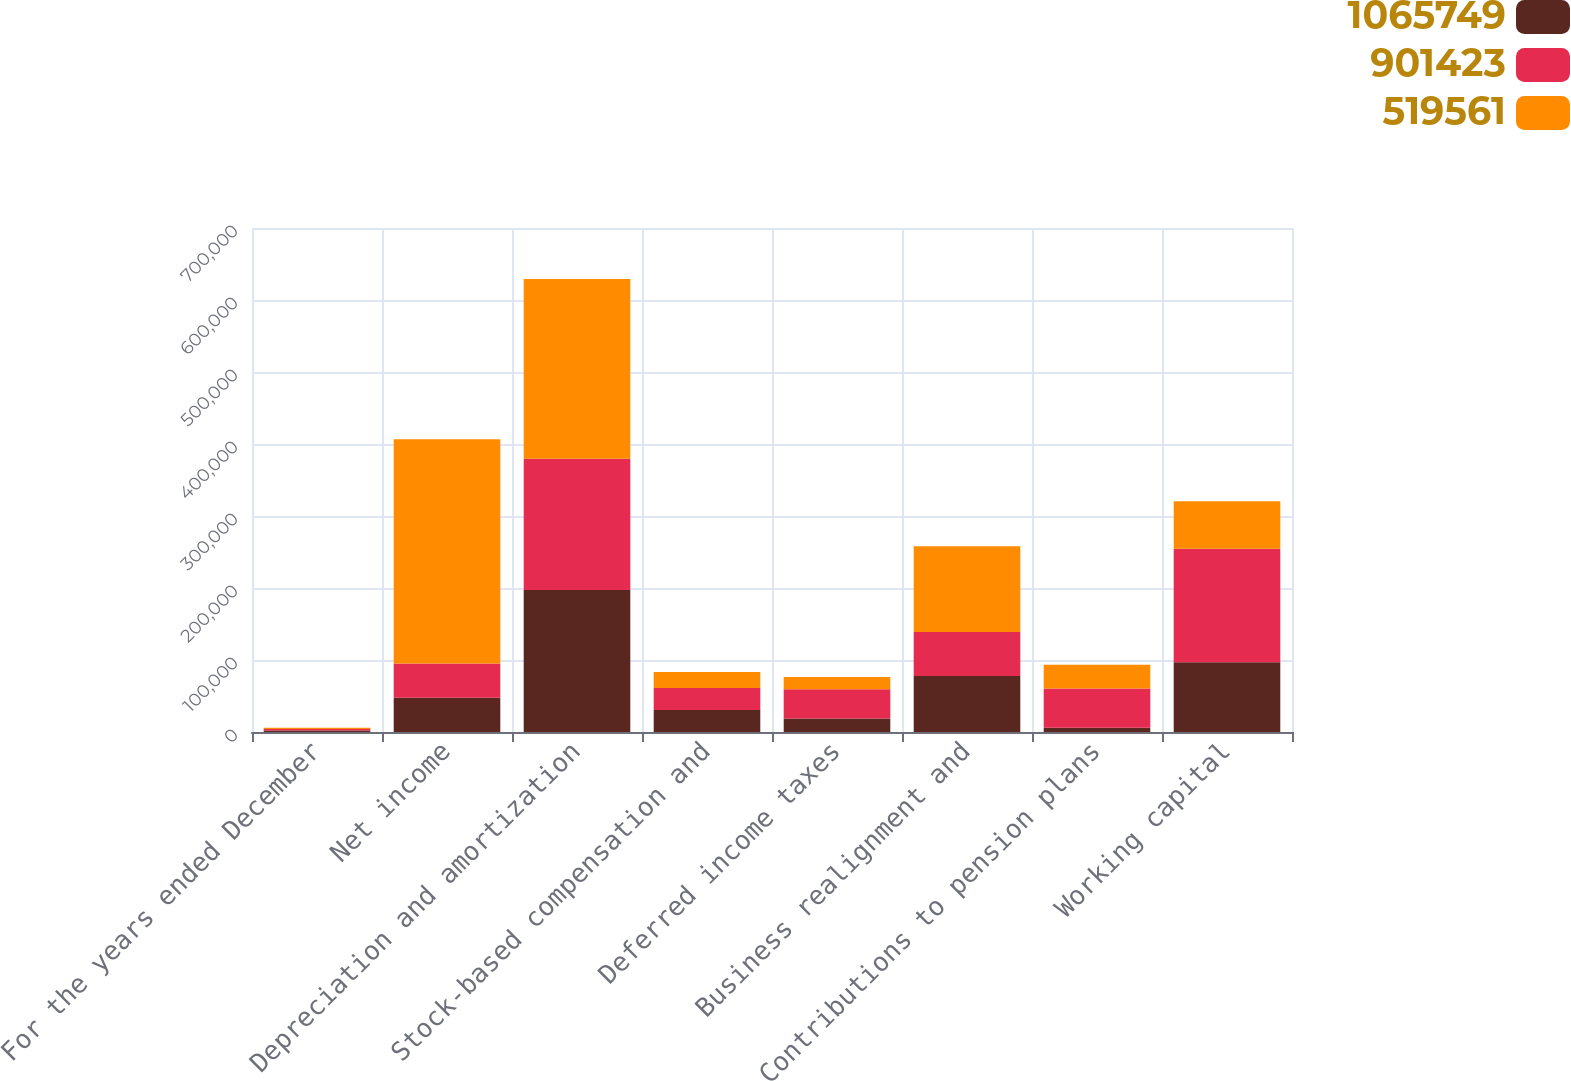<chart> <loc_0><loc_0><loc_500><loc_500><stacked_bar_chart><ecel><fcel>For the years ended December<fcel>Net income<fcel>Depreciation and amortization<fcel>Stock-based compensation and<fcel>Deferred income taxes<fcel>Business realignment and<fcel>Contributions to pension plans<fcel>Working capital<nl><fcel>1.06575e+06<fcel>2010<fcel>47517.5<fcel>197116<fcel>30670<fcel>18654<fcel>77935<fcel>6073<fcel>96853<nl><fcel>901423<fcel>2009<fcel>47517.5<fcel>182411<fcel>30472<fcel>40578<fcel>60823<fcel>54457<fcel>157812<nl><fcel>519561<fcel>2008<fcel>311405<fcel>249491<fcel>22196<fcel>17125<fcel>119117<fcel>32759<fcel>65791<nl></chart> 